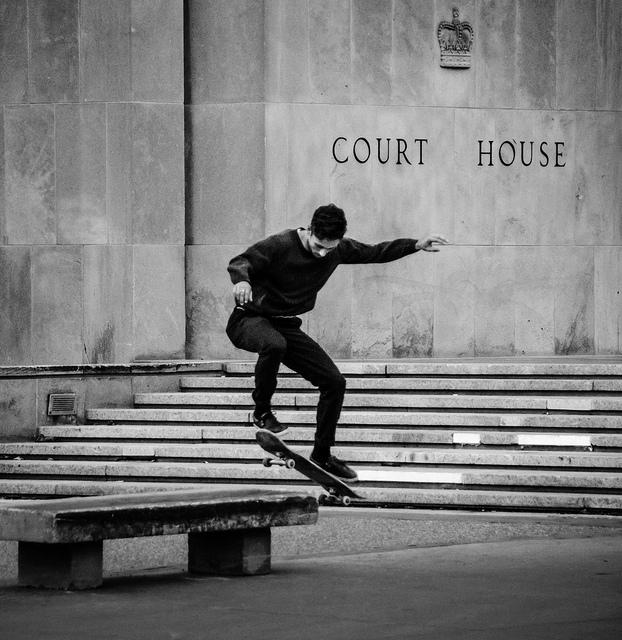In what type setting does the skateboarder skate here? court house 